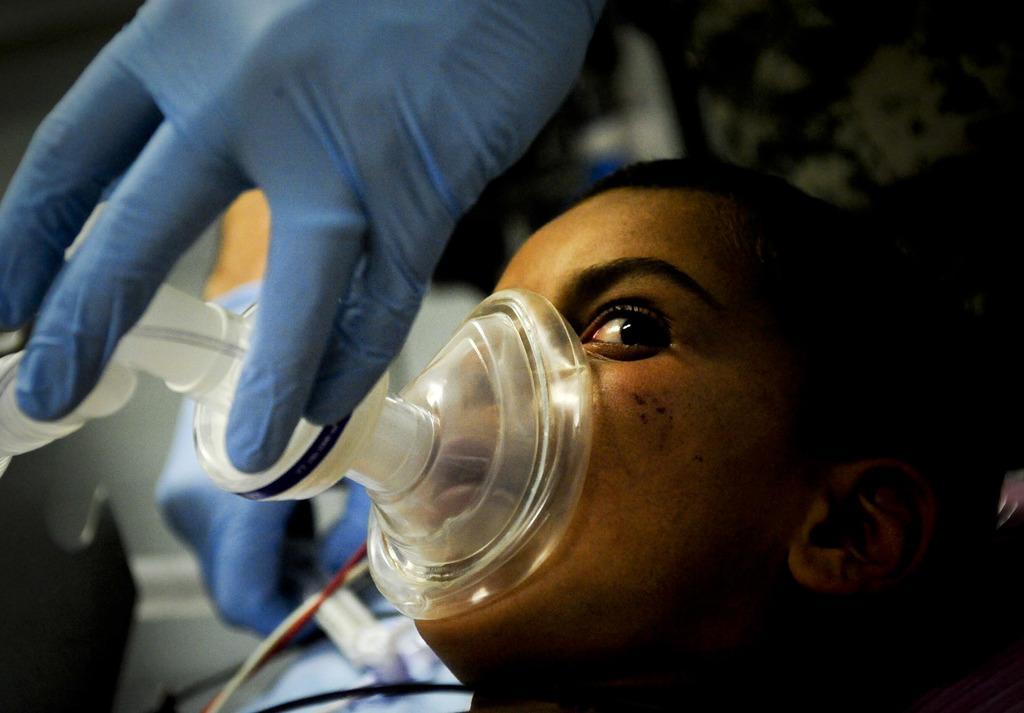Describe this image in one or two sentences. This is a zoomed in picture. In the foreground there is a person wearing a mask which seems to be the anesthesia mask. At the top we can see the hand of another person wearing blue color glove. 